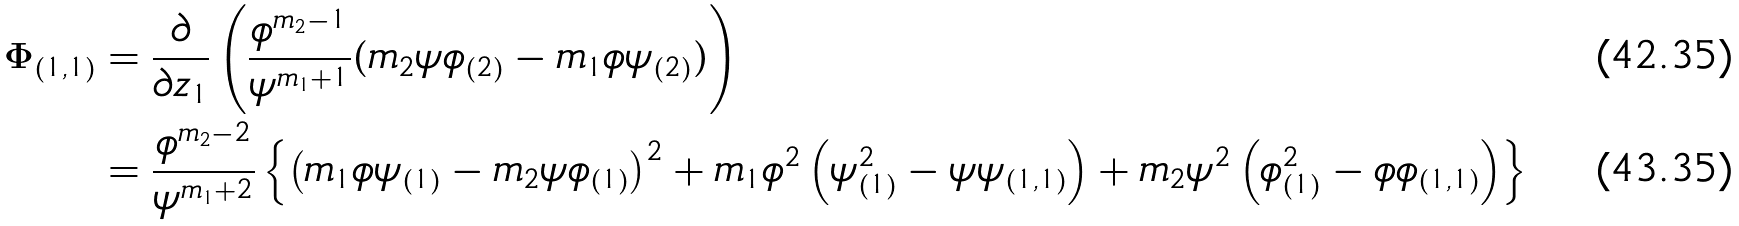Convert formula to latex. <formula><loc_0><loc_0><loc_500><loc_500>\Phi _ { ( 1 , 1 ) } & = \frac { \partial } { \partial z _ { 1 } } \left ( \frac { \phi ^ { m _ { 2 } - 1 } } { \psi ^ { m _ { 1 } + 1 } } ( m _ { 2 } \psi \phi _ { ( 2 ) } - m _ { 1 } \phi \psi _ { ( 2 ) } ) \right ) \\ & = \frac { \phi ^ { m _ { 2 } - 2 } } { \psi ^ { m _ { 1 } + 2 } } \left \{ \left ( m _ { 1 } \phi \psi _ { ( 1 ) } - m _ { 2 } \psi \phi _ { ( 1 ) } \right ) ^ { 2 } + m _ { 1 } \phi ^ { 2 } \left ( \psi _ { ( 1 ) } ^ { 2 } - \psi \psi _ { ( 1 , 1 ) } \right ) + m _ { 2 } \psi ^ { 2 } \left ( \phi _ { ( 1 ) } ^ { 2 } - \phi \phi _ { ( 1 , 1 ) } \right ) \right \}</formula> 